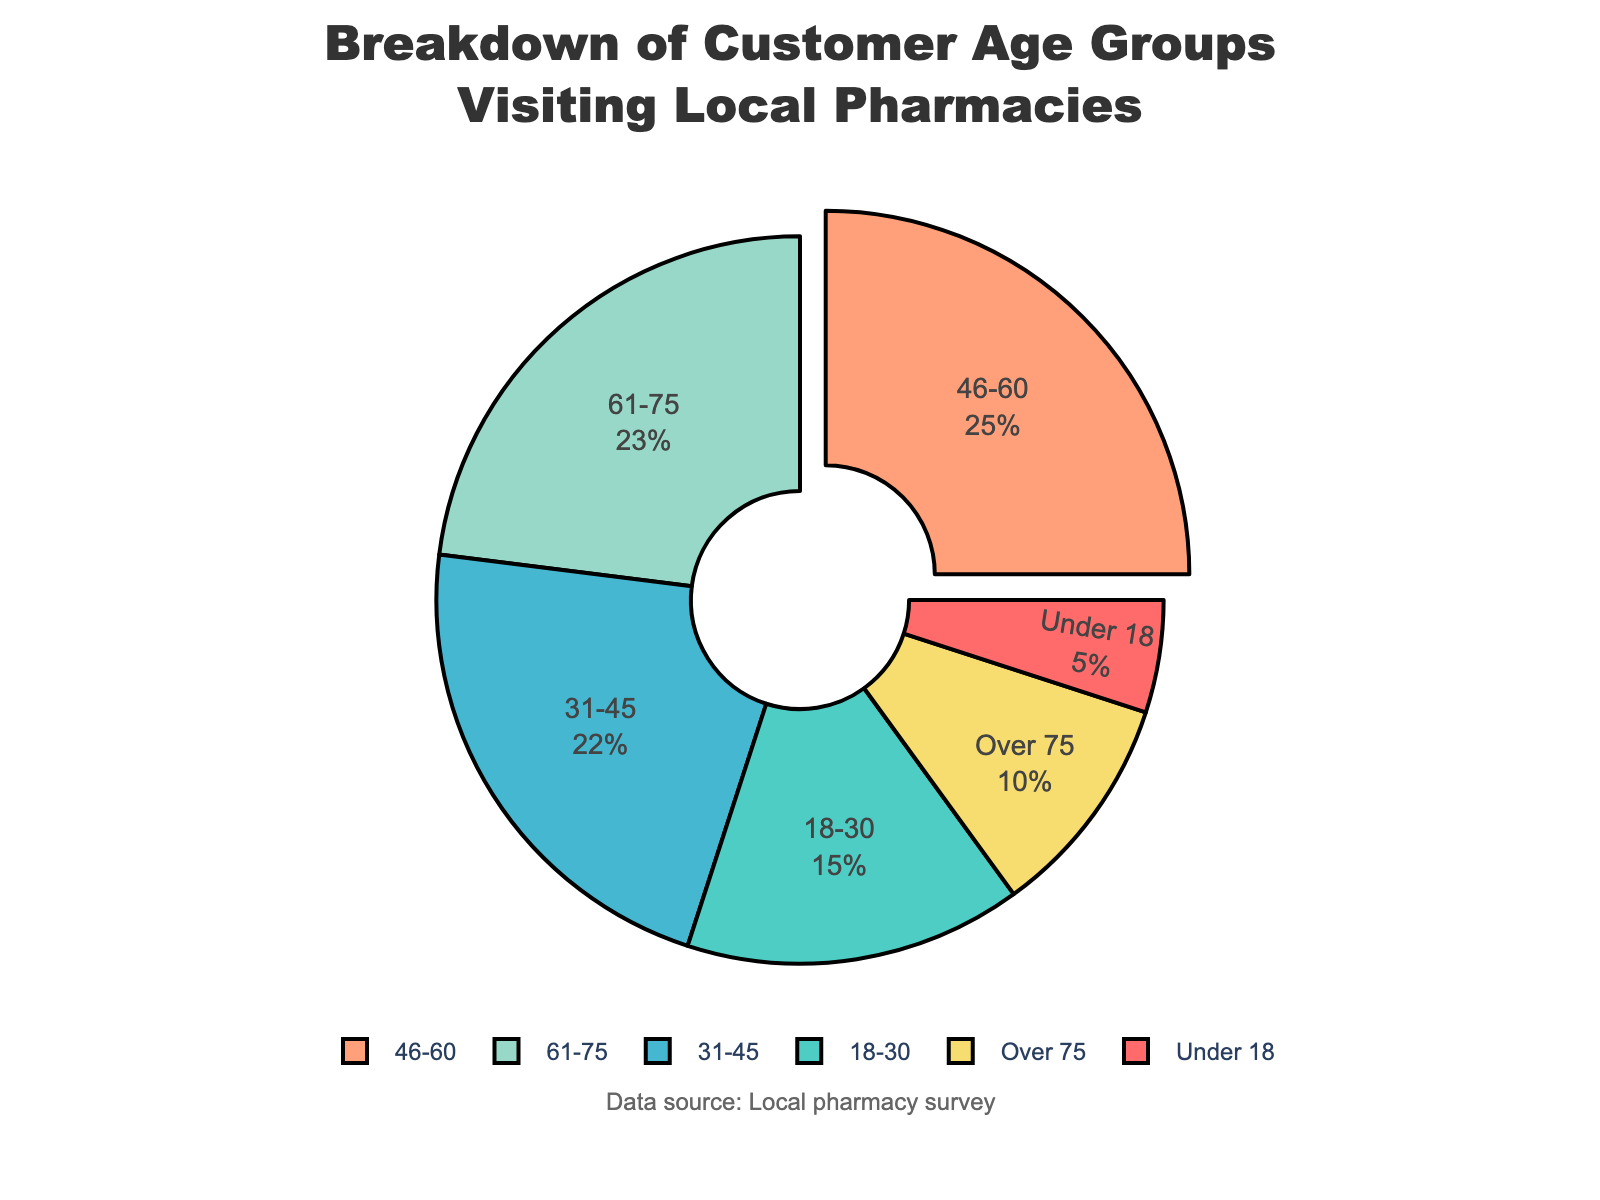What age group constitutes the largest percentage of customers visiting local pharmacies? The largest segment is visually highlighted (usually pulled out in pie charts) and represents 25% of the visitors. This corresponds to the 46-60 age group.
Answer: 46-60 Which age group has the smallest percentage of customers? The smallest segment is visually the smallest part of the pie chart and represents 5% of the visitors. This corresponds to the "Under 18" age group.
Answer: Under 18 What is the combined percentage of customers aged 31-45 and 46-60 visiting local pharmacies? Add the percentages for the 31-45 and 46-60 age groups. 22% + 25% = 47%.
Answer: 47% Are there more customers in the 61-75 age group than in the 18-30 age group? Compare the percentages of the 61-75 (23%) and 18-30 (15%) groups. 23% is greater than 15%.
Answer: Yes What is the total percentage of customers aged 60 and above? Add the percentages of the 61-75 and Over 75 age groups. 23% + 10% = 33%.
Answer: 33% Which age group is represented by the blue color in the chart? Identify which segment in the pie chart is colored blue; the colors are assigned in order where blue corresponds to the third segment. This segment corresponds to the 31-45 age group.
Answer: 31-45 How does the percentage of customers aged under 18 compare to those over 75? Compare the "Under 18" group (5%) to the "Over 75" group (10%). The “Over 75” group percentage is double that of the "Under 18" group.
Answer: Over 75 What age groups combined account for more than half of the customer visits to local pharmacies? Combine the groups to see which totals exceed 50%. Combining 46-60 (25%), 61-75 (23%), and 31-45 (22%) gives 70%.
Answer: 31-45, 46-60, and 61-75 What is the average percentage of customer visits across all age groups? Calculate the average by summing all percentages (5% + 15% + 22% + 25% + 23% + 10% = 100%) and then divide by the number of groups (6). 100% / 6 = 16.67%.
Answer: 16.67% Is the percentage of customers aged 46-75 higher than those aged under 45? Add the percentages of the 46-60 (25%) and 61-75 (23%) age groups, which totals to 48%. Compare this with the total of the Under 18 (5%), 18-30 (15%), and 31-45 (22%) groups, which totals to 42%. 48% is higher than 42%.
Answer: Yes 